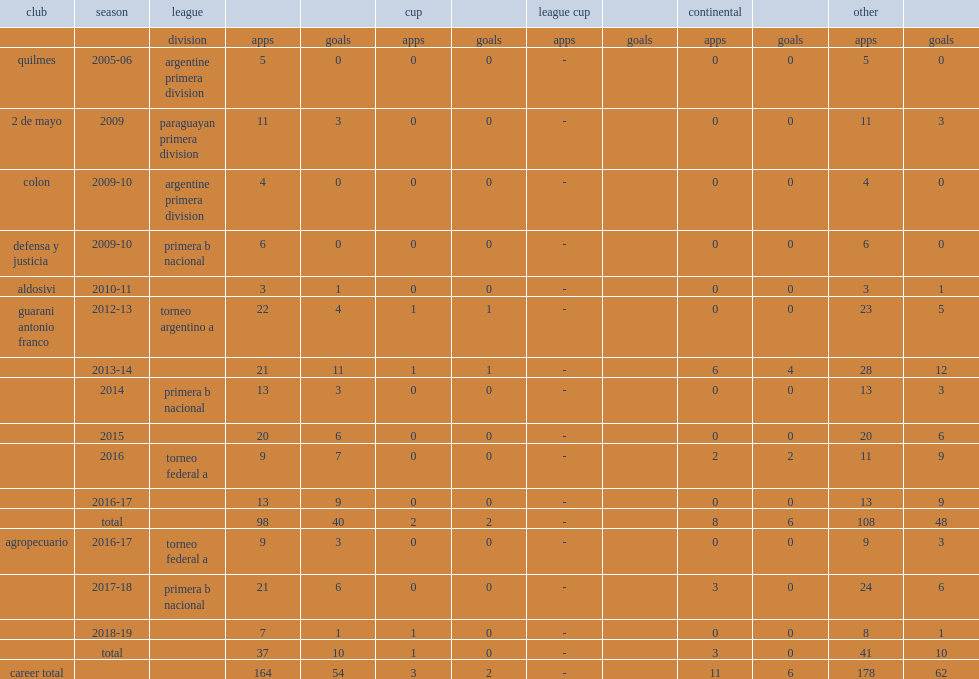What was the number of apps for argentine primera division during 2005-06 ? 5.0. Would you mind parsing the complete table? {'header': ['club', 'season', 'league', '', '', 'cup', '', 'league cup', '', 'continental', '', 'other', ''], 'rows': [['', '', 'division', 'apps', 'goals', 'apps', 'goals', 'apps', 'goals', 'apps', 'goals', 'apps', 'goals'], ['quilmes', '2005-06', 'argentine primera division', '5', '0', '0', '0', '-', '', '0', '0', '5', '0'], ['2 de mayo', '2009', 'paraguayan primera division', '11', '3', '0', '0', '-', '', '0', '0', '11', '3'], ['colon', '2009-10', 'argentine primera division', '4', '0', '0', '0', '-', '', '0', '0', '4', '0'], ['defensa y justicia', '2009-10', 'primera b nacional', '6', '0', '0', '0', '-', '', '0', '0', '6', '0'], ['aldosivi', '2010-11', '', '3', '1', '0', '0', '-', '', '0', '0', '3', '1'], ['guarani antonio franco', '2012-13', 'torneo argentino a', '22', '4', '1', '1', '-', '', '0', '0', '23', '5'], ['', '2013-14', '', '21', '11', '1', '1', '-', '', '6', '4', '28', '12'], ['', '2014', 'primera b nacional', '13', '3', '0', '0', '-', '', '0', '0', '13', '3'], ['', '2015', '', '20', '6', '0', '0', '-', '', '0', '0', '20', '6'], ['', '2016', 'torneo federal a', '9', '7', '0', '0', '-', '', '2', '2', '11', '9'], ['', '2016-17', '', '13', '9', '0', '0', '-', '', '0', '0', '13', '9'], ['', 'total', '', '98', '40', '2', '2', '-', '', '8', '6', '108', '48'], ['agropecuario', '2016-17', 'torneo federal a', '9', '3', '0', '0', '-', '', '0', '0', '9', '3'], ['', '2017-18', 'primera b nacional', '21', '6', '0', '0', '-', '', '3', '0', '24', '6'], ['', '2018-19', '', '7', '1', '1', '0', '-', '', '0', '0', '8', '1'], ['', 'total', '', '37', '10', '1', '0', '-', '', '3', '0', '41', '10'], ['career total', '', '', '164', '54', '3', '2', '-', '', '11', '6', '178', '62']]} 